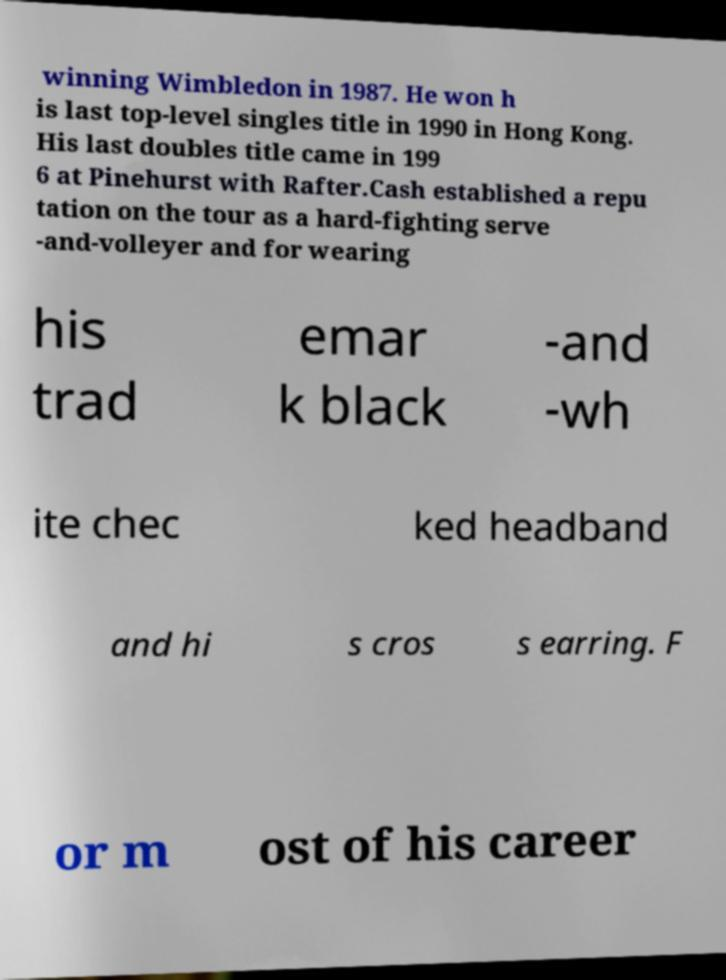Can you accurately transcribe the text from the provided image for me? winning Wimbledon in 1987. He won h is last top-level singles title in 1990 in Hong Kong. His last doubles title came in 199 6 at Pinehurst with Rafter.Cash established a repu tation on the tour as a hard-fighting serve -and-volleyer and for wearing his trad emar k black -and -wh ite chec ked headband and hi s cros s earring. F or m ost of his career 